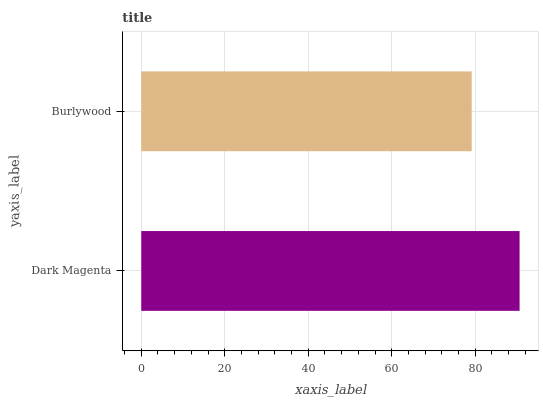Is Burlywood the minimum?
Answer yes or no. Yes. Is Dark Magenta the maximum?
Answer yes or no. Yes. Is Burlywood the maximum?
Answer yes or no. No. Is Dark Magenta greater than Burlywood?
Answer yes or no. Yes. Is Burlywood less than Dark Magenta?
Answer yes or no. Yes. Is Burlywood greater than Dark Magenta?
Answer yes or no. No. Is Dark Magenta less than Burlywood?
Answer yes or no. No. Is Dark Magenta the high median?
Answer yes or no. Yes. Is Burlywood the low median?
Answer yes or no. Yes. Is Burlywood the high median?
Answer yes or no. No. Is Dark Magenta the low median?
Answer yes or no. No. 